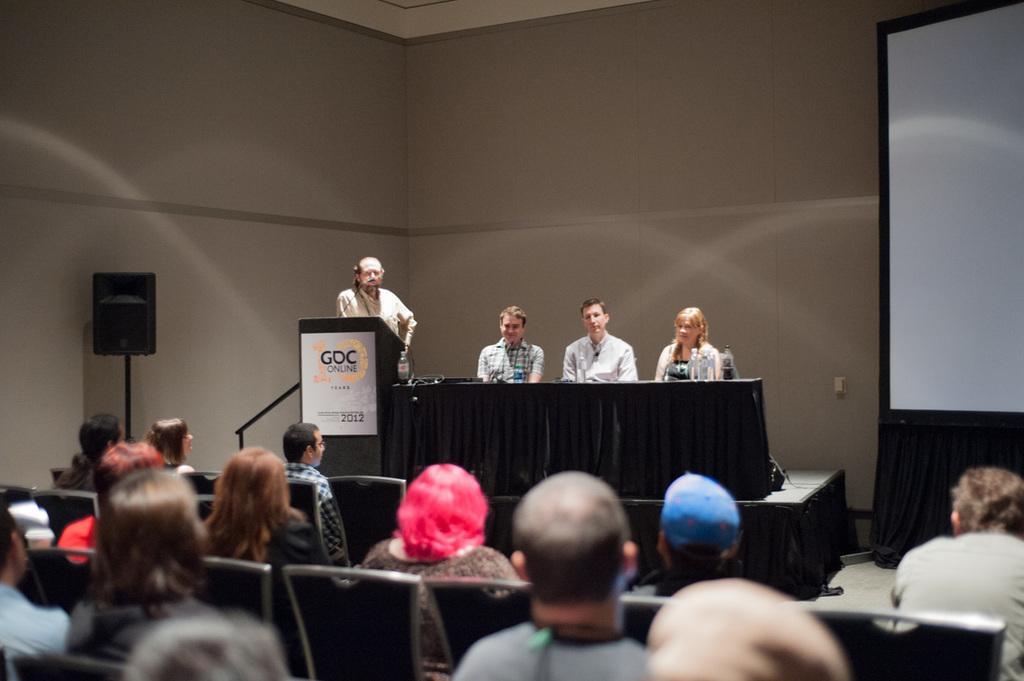Can you describe this image briefly? In the picture it looks like some conference, there are many people sitting in front of the stage and on the stage there are three people sitting in front of a table and on the left side there is a man standing in front of another table, on the left side there is a speaker in front of the wall and on the right side there is a presentation screen. 